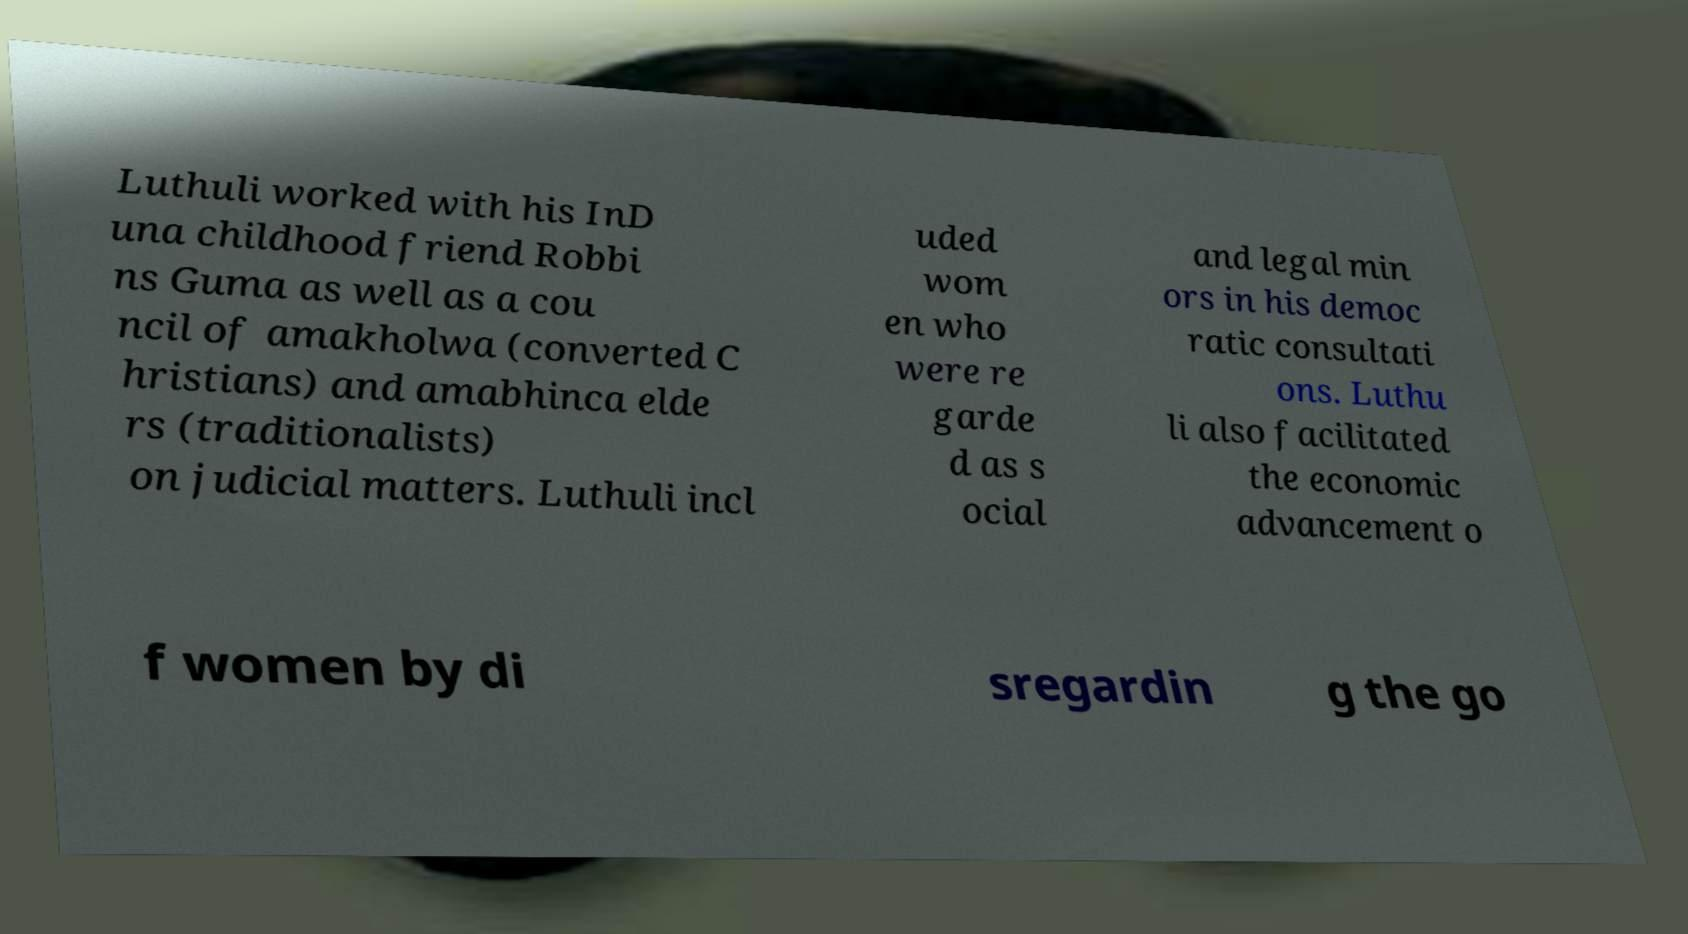For documentation purposes, I need the text within this image transcribed. Could you provide that? Luthuli worked with his InD una childhood friend Robbi ns Guma as well as a cou ncil of amakholwa (converted C hristians) and amabhinca elde rs (traditionalists) on judicial matters. Luthuli incl uded wom en who were re garde d as s ocial and legal min ors in his democ ratic consultati ons. Luthu li also facilitated the economic advancement o f women by di sregardin g the go 